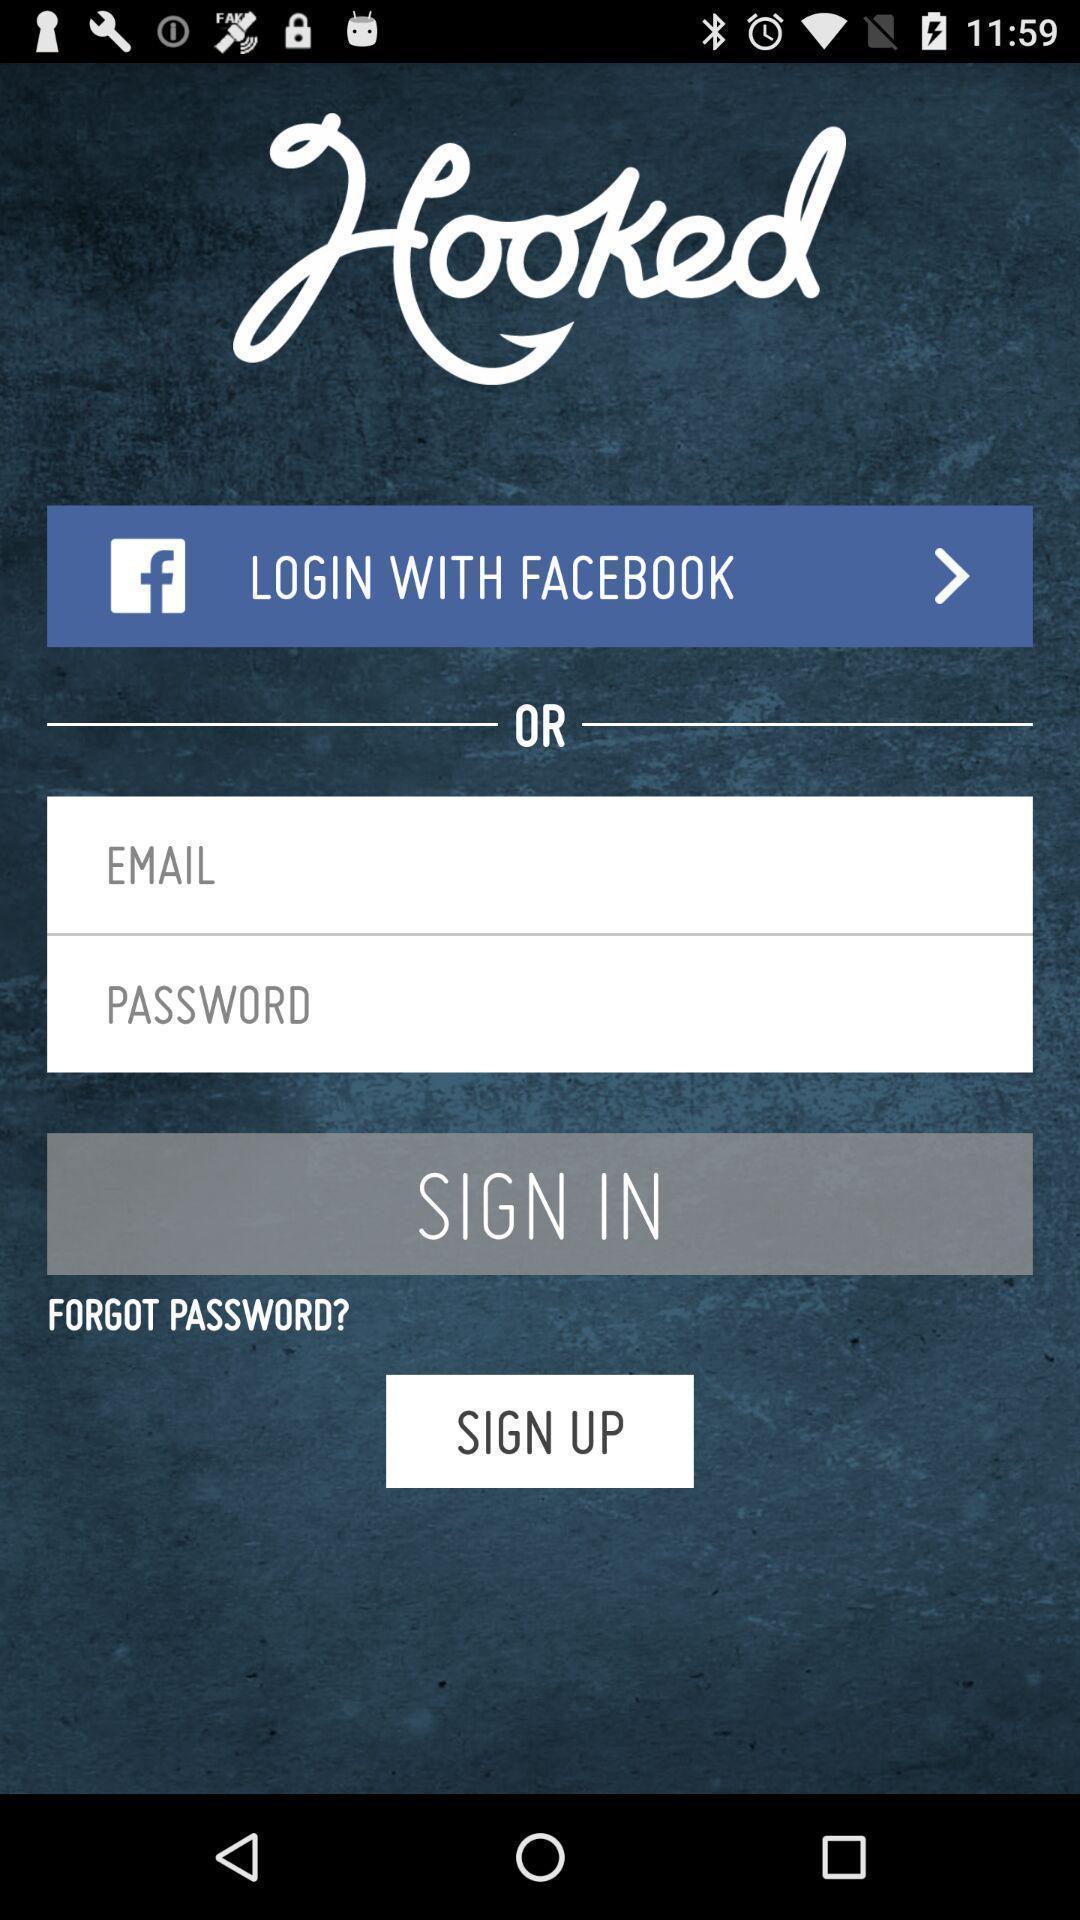Give me a summary of this screen capture. Sign in/sign up page of food application. 